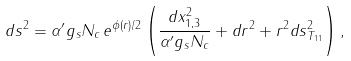Convert formula to latex. <formula><loc_0><loc_0><loc_500><loc_500>d s ^ { 2 } = \alpha ^ { \prime } g _ { s } N _ { c } \, e ^ { \phi ( r ) / 2 } \left ( \frac { d x _ { 1 , 3 } ^ { 2 } } { \alpha ^ { \prime } g _ { s } N _ { c } } + d r ^ { 2 } + r ^ { 2 } d s ^ { 2 } _ { T _ { 1 1 } } \right ) ,</formula> 